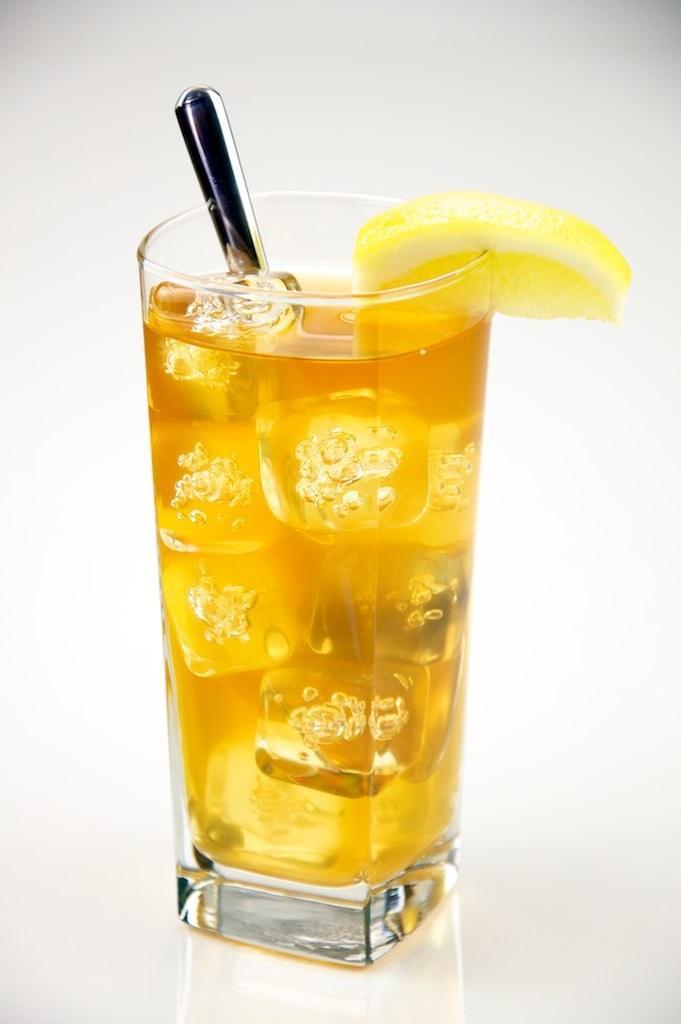How would you summarize this image in a sentence or two? This is a zoomed in picture. In the center there is a glass of a drink containing an object seems to be a spoon and a sliced lemon at the edge of the glass and the glass is placed on the top of a white color surface. In the background there is a white color object. 